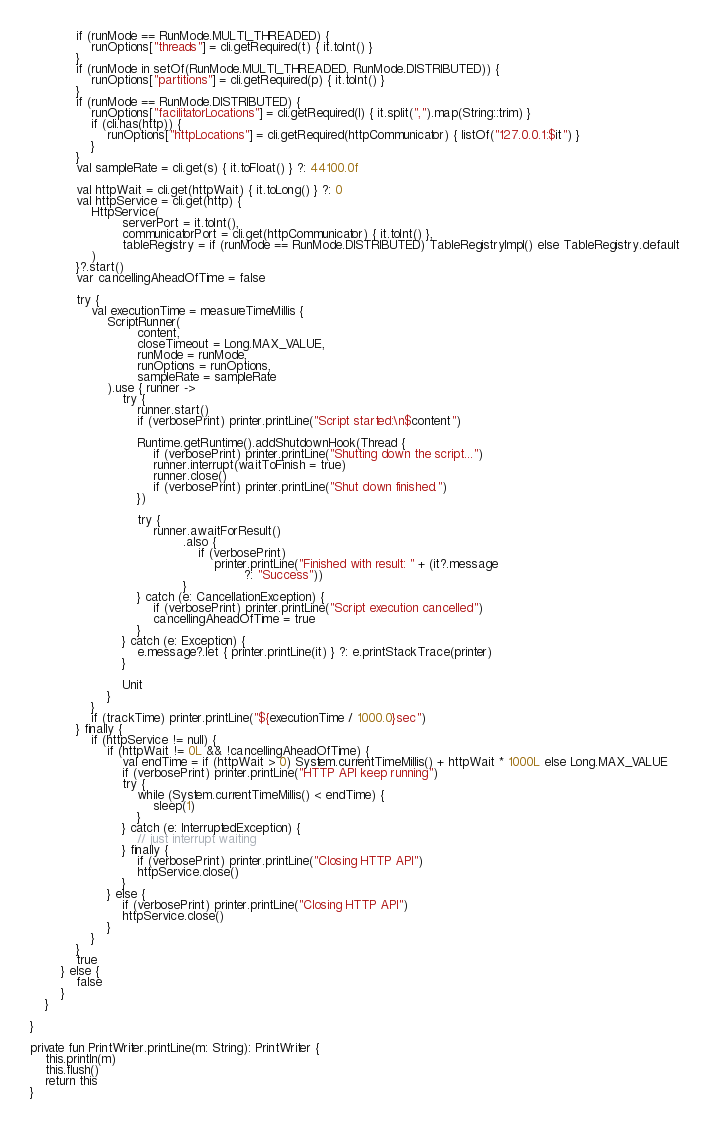Convert code to text. <code><loc_0><loc_0><loc_500><loc_500><_Kotlin_>            if (runMode == RunMode.MULTI_THREADED) {
                runOptions["threads"] = cli.getRequired(t) { it.toInt() }
            }
            if (runMode in setOf(RunMode.MULTI_THREADED, RunMode.DISTRIBUTED)) {
                runOptions["partitions"] = cli.getRequired(p) { it.toInt() }
            }
            if (runMode == RunMode.DISTRIBUTED) {
                runOptions["facilitatorLocations"] = cli.getRequired(l) { it.split(",").map(String::trim) }
                if (cli.has(http)) {
                    runOptions["httpLocations"] = cli.getRequired(httpCommunicator) { listOf("127.0.0.1:$it") }
                }
            }
            val sampleRate = cli.get(s) { it.toFloat() } ?: 44100.0f

            val httpWait = cli.get(httpWait) { it.toLong() } ?: 0
            val httpService = cli.get(http) {
                HttpService(
                        serverPort = it.toInt(),
                        communicatorPort = cli.get(httpCommunicator) { it.toInt() },
                        tableRegistry = if (runMode == RunMode.DISTRIBUTED) TableRegistryImpl() else TableRegistry.default
                )
            }?.start()
            var cancellingAheadOfTime = false

            try {
                val executionTime = measureTimeMillis {
                    ScriptRunner(
                            content,
                            closeTimeout = Long.MAX_VALUE,
                            runMode = runMode,
                            runOptions = runOptions,
                            sampleRate = sampleRate
                    ).use { runner ->
                        try {
                            runner.start()
                            if (verbosePrint) printer.printLine("Script started:\n$content")

                            Runtime.getRuntime().addShutdownHook(Thread {
                                if (verbosePrint) printer.printLine("Shutting down the script...")
                                runner.interrupt(waitToFinish = true)
                                runner.close()
                                if (verbosePrint) printer.printLine("Shut down finished.")
                            })

                            try {
                                runner.awaitForResult()
                                        .also {
                                            if (verbosePrint)
                                                printer.printLine("Finished with result: " + (it?.message
                                                        ?: "Success"))
                                        }
                            } catch (e: CancellationException) {
                                if (verbosePrint) printer.printLine("Script execution cancelled")
                                cancellingAheadOfTime = true
                            }
                        } catch (e: Exception) {
                            e.message?.let { printer.printLine(it) } ?: e.printStackTrace(printer)
                        }

                        Unit
                    }
                }
                if (trackTime) printer.printLine("${executionTime / 1000.0}sec")
            } finally {
                if (httpService != null) {
                    if (httpWait != 0L && !cancellingAheadOfTime) {
                        val endTime = if (httpWait > 0) System.currentTimeMillis() + httpWait * 1000L else Long.MAX_VALUE
                        if (verbosePrint) printer.printLine("HTTP API keep running")
                        try {
                            while (System.currentTimeMillis() < endTime) {
                                sleep(1)
                            }
                        } catch (e: InterruptedException) {
                            // just interrupt waiting
                        } finally {
                            if (verbosePrint) printer.printLine("Closing HTTP API")
                            httpService.close()
                        }
                    } else {
                        if (verbosePrint) printer.printLine("Closing HTTP API")
                        httpService.close()
                    }
                }
            }
            true
        } else {
            false
        }
    }

}

private fun PrintWriter.printLine(m: String): PrintWriter {
    this.println(m)
    this.flush()
    return this
}</code> 